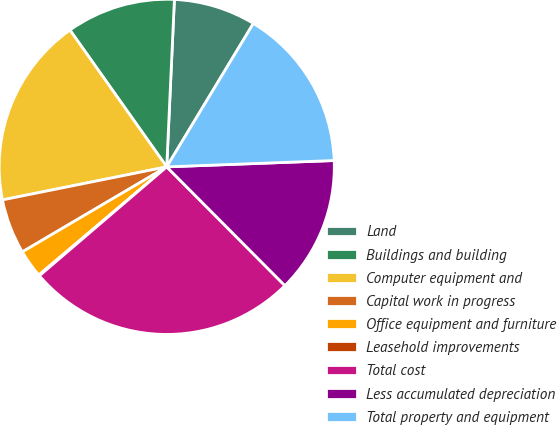<chart> <loc_0><loc_0><loc_500><loc_500><pie_chart><fcel>Land<fcel>Buildings and building<fcel>Computer equipment and<fcel>Capital work in progress<fcel>Office equipment and furniture<fcel>Leasehold improvements<fcel>Total cost<fcel>Less accumulated depreciation<fcel>Total property and equipment<nl><fcel>7.92%<fcel>10.53%<fcel>18.36%<fcel>5.31%<fcel>2.7%<fcel>0.09%<fcel>26.2%<fcel>13.14%<fcel>15.75%<nl></chart> 